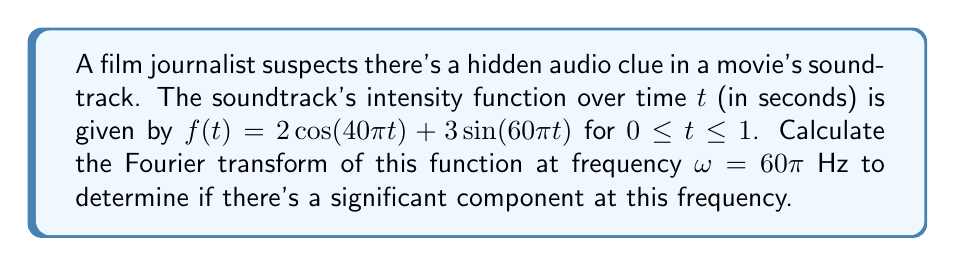Can you solve this math problem? To solve this problem, we'll follow these steps:

1) The Fourier transform of a function $f(t)$ is defined as:

   $$F(\omega) = \int_{-\infty}^{\infty} f(t) e^{-i\omega t} dt$$

2) In our case, the function is defined only for $0 \leq t \leq 1$, so we'll integrate from 0 to 1:

   $$F(60\pi) = \int_{0}^{1} [2\cos(40\pi t) + 3\sin(60\pi t)] e^{-i60\pi t} dt$$

3) We can split this into two integrals:

   $$F(60\pi) = 2\int_{0}^{1} \cos(40\pi t)e^{-i60\pi t} dt + 3\int_{0}^{1} \sin(60\pi t)e^{-i60\pi t} dt$$

4) For the first integral, we can use Euler's formula: $\cos(40\pi t) = \frac{e^{i40\pi t} + e^{-i40\pi t}}{2}$

   $$2\int_{0}^{1} \cos(40\pi t)e^{-i60\pi t} dt = \int_{0}^{1} (e^{-i20\pi t} + e^{-i100\pi t}) dt$$

5) For the second integral, we can use: $\sin(60\pi t) = \frac{e^{i60\pi t} - e^{-i60\pi t}}{2i}$

   $$3\int_{0}^{1} \sin(60\pi t)e^{-i60\pi t} dt = \frac{3}{2i}\int_{0}^{1} (1 - e^{-i120\pi t}) dt$$

6) Evaluating these integrals:

   $$\int_{0}^{1} (e^{-i20\pi t} + e^{-i100\pi t}) dt = \frac{1-e^{-i20\pi}}{i20\pi} + \frac{1-e^{-i100\pi}}{i100\pi} = 0$$

   $$\frac{3}{2i}\int_{0}^{1} (1 - e^{-i120\pi t}) dt = \frac{3}{2i}(1 - 0) = \frac{3}{2i}$$

7) Adding these results:

   $$F(60\pi) = 0 + \frac{3}{2i} = \frac{3}{2i}$$

8) This can be written in the form $a + bi$ as:

   $$F(60\pi) = 0 - \frac{3}{2}i$$
Answer: $-\frac{3}{2}i$ 